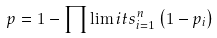Convert formula to latex. <formula><loc_0><loc_0><loc_500><loc_500>p = 1 - \prod \lim i t s _ { i = 1 } ^ { n } \left ( 1 - p _ { i } \right )</formula> 